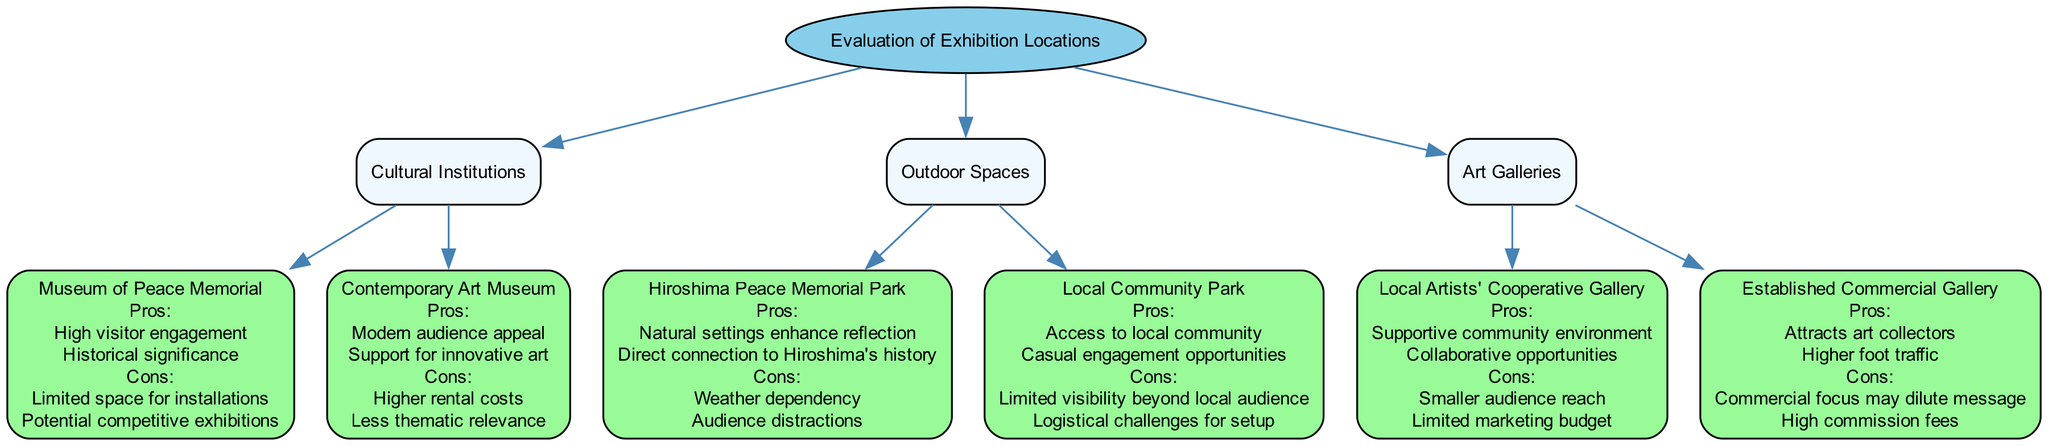What are the pros of showcasing in the Museum of Peace Memorial? The Museum of Peace Memorial has specific pros listed, which are high visitor engagement and historical significance.
Answer: High visitor engagement, historical significance What are the cons of showcasing in the Contemporary Art Museum? The cons for the Contemporary Art Museum include higher rental costs and less thematic relevance as indicated in the diagram.
Answer: Higher rental costs, less thematic relevance How many types of exhibition locations are evaluated? There are three main types of exhibition locations evaluated in the diagram: Cultural Institutions, Outdoor Spaces, and Art Galleries.
Answer: 3 What is a pro of showcasing in the Hiroshima Peace Memorial Park? According to the diagram, one pro of showcasing in the Hiroshima Peace Memorial Park is that natural settings enhance reflection.
Answer: Natural settings enhance reflection Which exhibition location has a limited marketing budget? The Local Artists' Cooperative Gallery is indicated in the diagram as having a limited marketing budget.
Answer: Local Artists' Cooperative Gallery What is the total number of cons listed for the Established Commercial Gallery? The diagram specifies two cons for the Established Commercial Gallery: commercial focus may dilute message and high commission fees. Thus, the total is two.
Answer: 2 Which exhibition location offers collaborative opportunities? The Local Artists' Cooperative Gallery is noted for offering collaborative opportunities in the diagram.
Answer: Local Artists' Cooperative Gallery What are the cons listed for Local Community Park? For the Local Community Park, the cons include limited visibility beyond local audience and logistical challenges for setup as stated in the diagram.
Answer: Limited visibility beyond local audience, logistical challenges for setup 